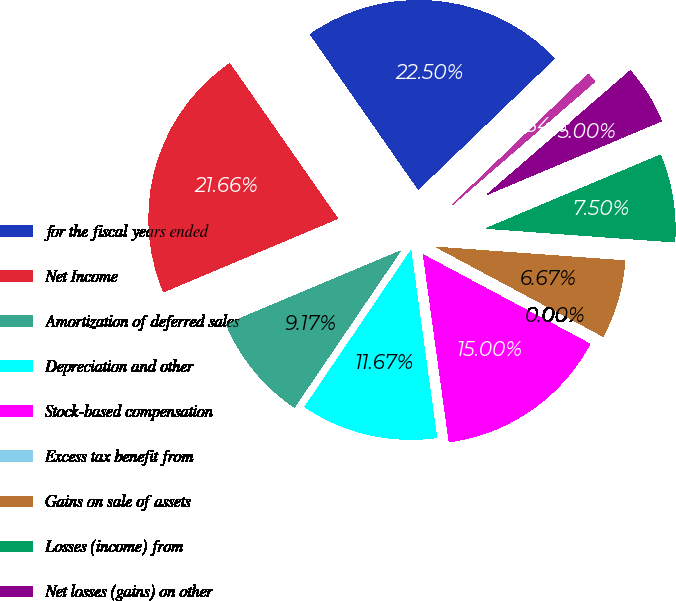Convert chart. <chart><loc_0><loc_0><loc_500><loc_500><pie_chart><fcel>for the fiscal years ended<fcel>Net Income<fcel>Amortization of deferred sales<fcel>Depreciation and other<fcel>Stock-based compensation<fcel>Excess tax benefit from<fcel>Gains on sale of assets<fcel>Losses (income) from<fcel>Net losses (gains) on other<fcel>Net gains of consolidated<nl><fcel>22.5%<fcel>21.66%<fcel>9.17%<fcel>11.67%<fcel>15.0%<fcel>0.0%<fcel>6.67%<fcel>7.5%<fcel>5.0%<fcel>0.84%<nl></chart> 